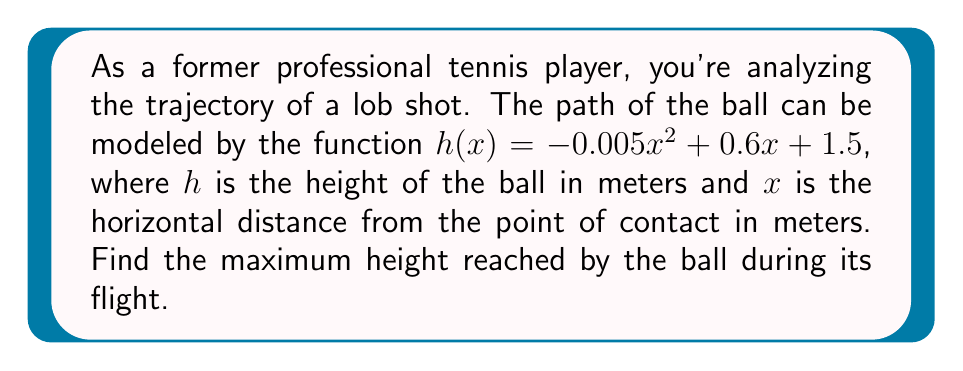Solve this math problem. To find the maximum height of the lob shot, we need to use optimization techniques involving derivatives. Here's a step-by-step approach:

1) The function given is $h(x) = -0.005x^2 + 0.6x + 1.5$

2) To find the maximum point, we need to find where the derivative equals zero. Let's calculate the derivative:

   $h'(x) = -0.01x + 0.6$

3) Set the derivative equal to zero and solve for x:

   $-0.01x + 0.6 = 0$
   $-0.01x = -0.6$
   $x = 60$

4) This critical point (x = 60) could be a maximum or minimum. To confirm it's a maximum, we can check the second derivative:

   $h''(x) = -0.01$

   Since $h''(x)$ is negative, the critical point is indeed a maximum.

5) To find the maximum height, we plug x = 60 back into our original function:

   $h(60) = -0.005(60)^2 + 0.6(60) + 1.5$
          $= -18 + 36 + 1.5$
          $= 19.5$

Therefore, the maximum height reached by the ball is 19.5 meters.
Answer: 19.5 meters 